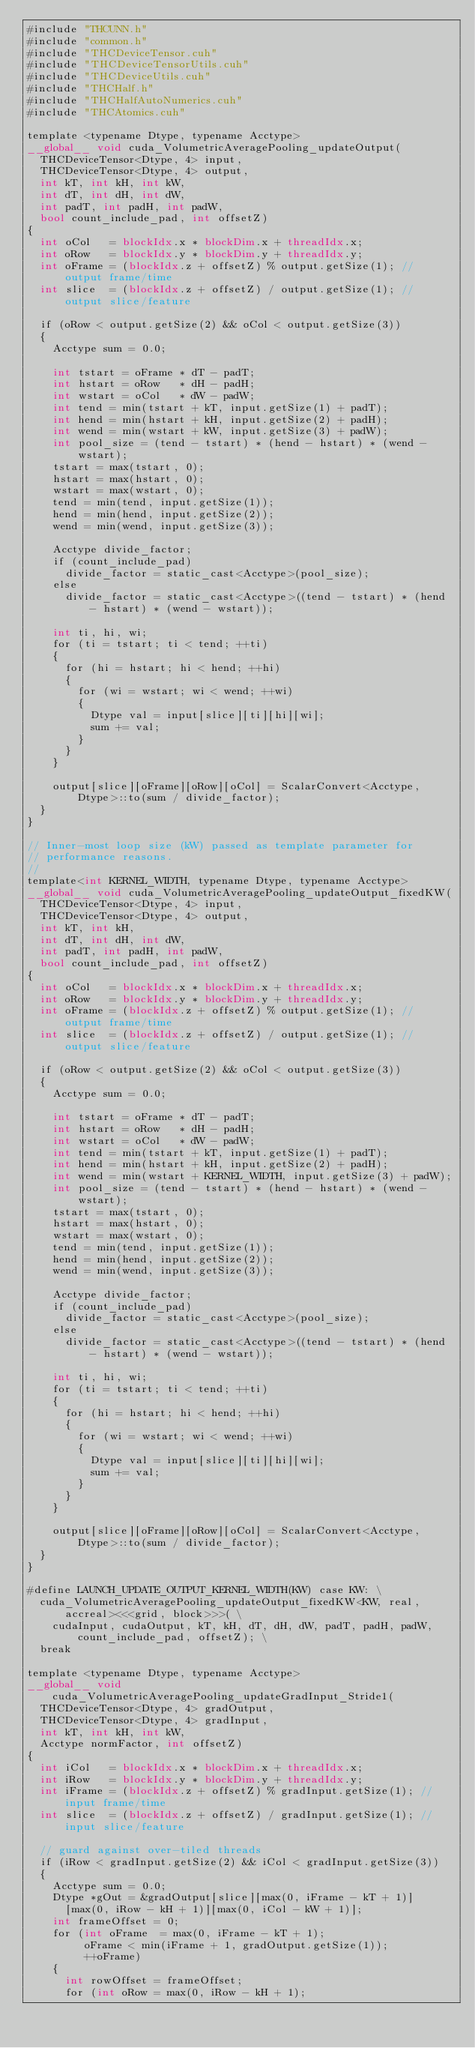<code> <loc_0><loc_0><loc_500><loc_500><_Cuda_>#include "THCUNN.h"
#include "common.h"
#include "THCDeviceTensor.cuh"
#include "THCDeviceTensorUtils.cuh"
#include "THCDeviceUtils.cuh"
#include "THCHalf.h"
#include "THCHalfAutoNumerics.cuh"
#include "THCAtomics.cuh"

template <typename Dtype, typename Acctype>
__global__ void cuda_VolumetricAveragePooling_updateOutput(
  THCDeviceTensor<Dtype, 4> input,
  THCDeviceTensor<Dtype, 4> output,
  int kT, int kH, int kW,
  int dT, int dH, int dW,
  int padT, int padH, int padW,
  bool count_include_pad, int offsetZ)
{
  int oCol   = blockIdx.x * blockDim.x + threadIdx.x;
  int oRow   = blockIdx.y * blockDim.y + threadIdx.y;
  int oFrame = (blockIdx.z + offsetZ) % output.getSize(1); // output frame/time
  int slice  = (blockIdx.z + offsetZ) / output.getSize(1); // output slice/feature

  if (oRow < output.getSize(2) && oCol < output.getSize(3))
  {
    Acctype sum = 0.0;

    int tstart = oFrame * dT - padT;
    int hstart = oRow   * dH - padH;
    int wstart = oCol   * dW - padW;
    int tend = min(tstart + kT, input.getSize(1) + padT);
    int hend = min(hstart + kH, input.getSize(2) + padH);
    int wend = min(wstart + kW, input.getSize(3) + padW);
    int pool_size = (tend - tstart) * (hend - hstart) * (wend - wstart);
    tstart = max(tstart, 0);
    hstart = max(hstart, 0);
    wstart = max(wstart, 0);
    tend = min(tend, input.getSize(1));
    hend = min(hend, input.getSize(2));
    wend = min(wend, input.getSize(3));

    Acctype divide_factor;
    if (count_include_pad)
      divide_factor = static_cast<Acctype>(pool_size);
    else
      divide_factor = static_cast<Acctype>((tend - tstart) * (hend - hstart) * (wend - wstart));

    int ti, hi, wi;
    for (ti = tstart; ti < tend; ++ti)
    {
      for (hi = hstart; hi < hend; ++hi)
      {
        for (wi = wstart; wi < wend; ++wi)
        {
          Dtype val = input[slice][ti][hi][wi];
          sum += val;
        }
      }
    }

    output[slice][oFrame][oRow][oCol] = ScalarConvert<Acctype, Dtype>::to(sum / divide_factor);
  }
}

// Inner-most loop size (kW) passed as template parameter for
// performance reasons.
//
template<int KERNEL_WIDTH, typename Dtype, typename Acctype>
__global__ void cuda_VolumetricAveragePooling_updateOutput_fixedKW(
  THCDeviceTensor<Dtype, 4> input,
  THCDeviceTensor<Dtype, 4> output,
  int kT, int kH,
  int dT, int dH, int dW,
  int padT, int padH, int padW,
  bool count_include_pad, int offsetZ)
{
  int oCol   = blockIdx.x * blockDim.x + threadIdx.x;
  int oRow   = blockIdx.y * blockDim.y + threadIdx.y;
  int oFrame = (blockIdx.z + offsetZ) % output.getSize(1); // output frame/time
  int slice  = (blockIdx.z + offsetZ) / output.getSize(1); // output slice/feature

  if (oRow < output.getSize(2) && oCol < output.getSize(3))
  {
    Acctype sum = 0.0;

    int tstart = oFrame * dT - padT;
    int hstart = oRow   * dH - padH;
    int wstart = oCol   * dW - padW;
    int tend = min(tstart + kT, input.getSize(1) + padT);
    int hend = min(hstart + kH, input.getSize(2) + padH);
    int wend = min(wstart + KERNEL_WIDTH, input.getSize(3) + padW);
    int pool_size = (tend - tstart) * (hend - hstart) * (wend - wstart);
    tstart = max(tstart, 0);
    hstart = max(hstart, 0);
    wstart = max(wstart, 0);
    tend = min(tend, input.getSize(1));
    hend = min(hend, input.getSize(2));
    wend = min(wend, input.getSize(3));

    Acctype divide_factor;
    if (count_include_pad)
      divide_factor = static_cast<Acctype>(pool_size);
    else
      divide_factor = static_cast<Acctype>((tend - tstart) * (hend - hstart) * (wend - wstart));

    int ti, hi, wi;
    for (ti = tstart; ti < tend; ++ti)
    {
      for (hi = hstart; hi < hend; ++hi)
      {
        for (wi = wstart; wi < wend; ++wi)
        {
          Dtype val = input[slice][ti][hi][wi];
          sum += val;
        }
      }
    }

    output[slice][oFrame][oRow][oCol] = ScalarConvert<Acctype, Dtype>::to(sum / divide_factor);
  }
}

#define LAUNCH_UPDATE_OUTPUT_KERNEL_WIDTH(KW) case KW: \
  cuda_VolumetricAveragePooling_updateOutput_fixedKW<KW, real, accreal><<<grid, block>>>( \
    cudaInput, cudaOutput, kT, kH, dT, dH, dW, padT, padH, padW, count_include_pad, offsetZ); \
  break

template <typename Dtype, typename Acctype>
__global__ void cuda_VolumetricAveragePooling_updateGradInput_Stride1(
  THCDeviceTensor<Dtype, 4> gradOutput,
  THCDeviceTensor<Dtype, 4> gradInput,
  int kT, int kH, int kW,
  Acctype normFactor, int offsetZ)
{
  int iCol   = blockIdx.x * blockDim.x + threadIdx.x;
  int iRow   = blockIdx.y * blockDim.y + threadIdx.y;
  int iFrame = (blockIdx.z + offsetZ) % gradInput.getSize(1); // input frame/time
  int slice  = (blockIdx.z + offsetZ) / gradInput.getSize(1); // input slice/feature

  // guard against over-tiled threads
  if (iRow < gradInput.getSize(2) && iCol < gradInput.getSize(3))
  {
    Acctype sum = 0.0;
    Dtype *gOut = &gradOutput[slice][max(0, iFrame - kT + 1)]
      [max(0, iRow - kH + 1)][max(0, iCol - kW + 1)];
    int frameOffset = 0;
    for (int oFrame  = max(0, iFrame - kT + 1);
         oFrame < min(iFrame + 1, gradOutput.getSize(1));
         ++oFrame)
    {
      int rowOffset = frameOffset;
      for (int oRow = max(0, iRow - kH + 1);</code> 